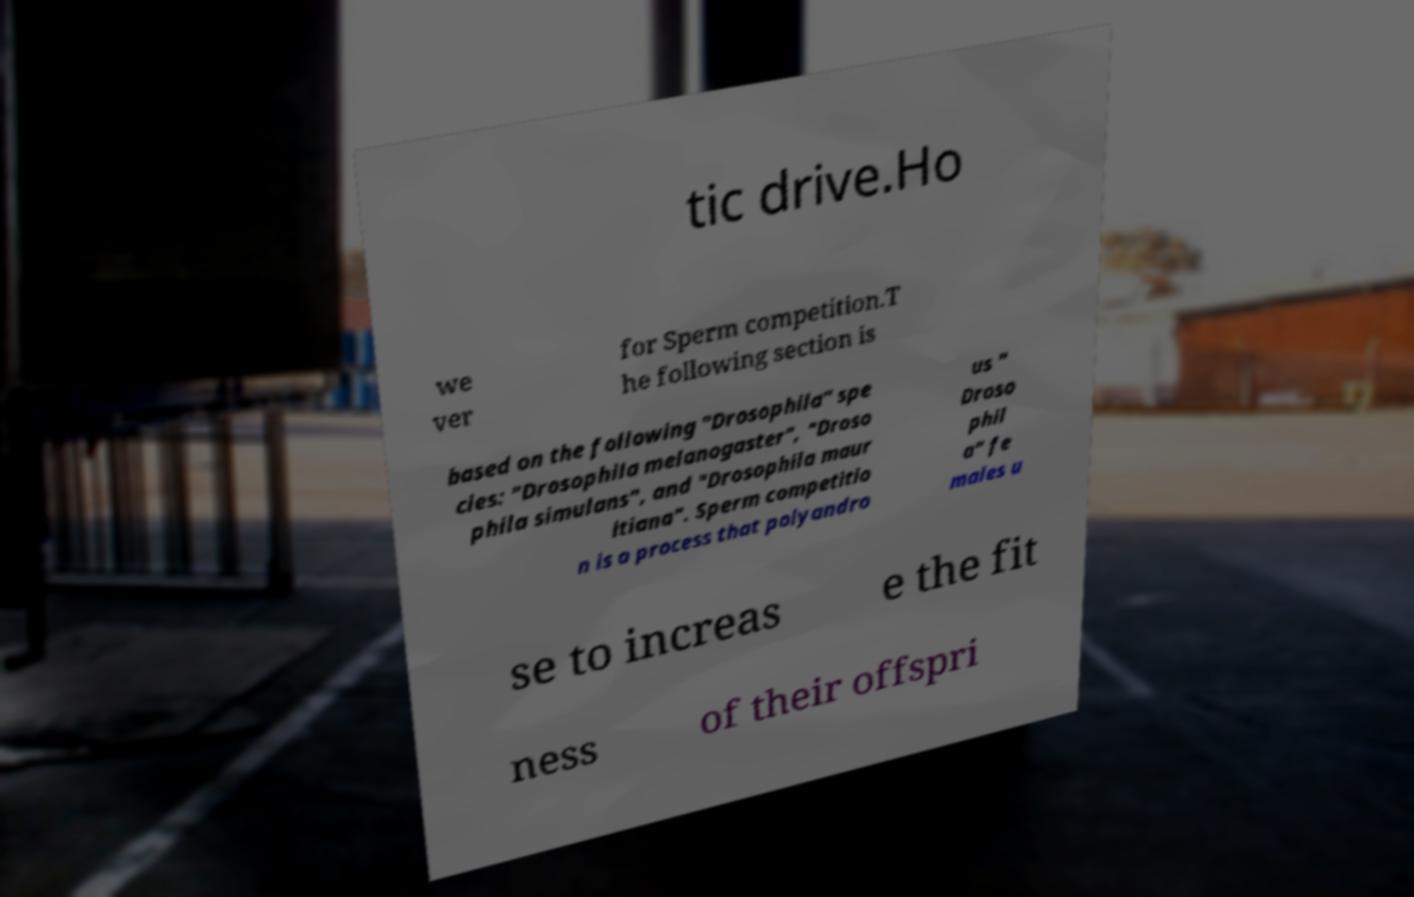Could you extract and type out the text from this image? tic drive.Ho we ver for Sperm competition.T he following section is based on the following "Drosophila" spe cies: "Drosophila melanogaster", "Droso phila simulans", and "Drosophila maur itiana". Sperm competitio n is a process that polyandro us " Droso phil a" fe males u se to increas e the fit ness of their offspri 